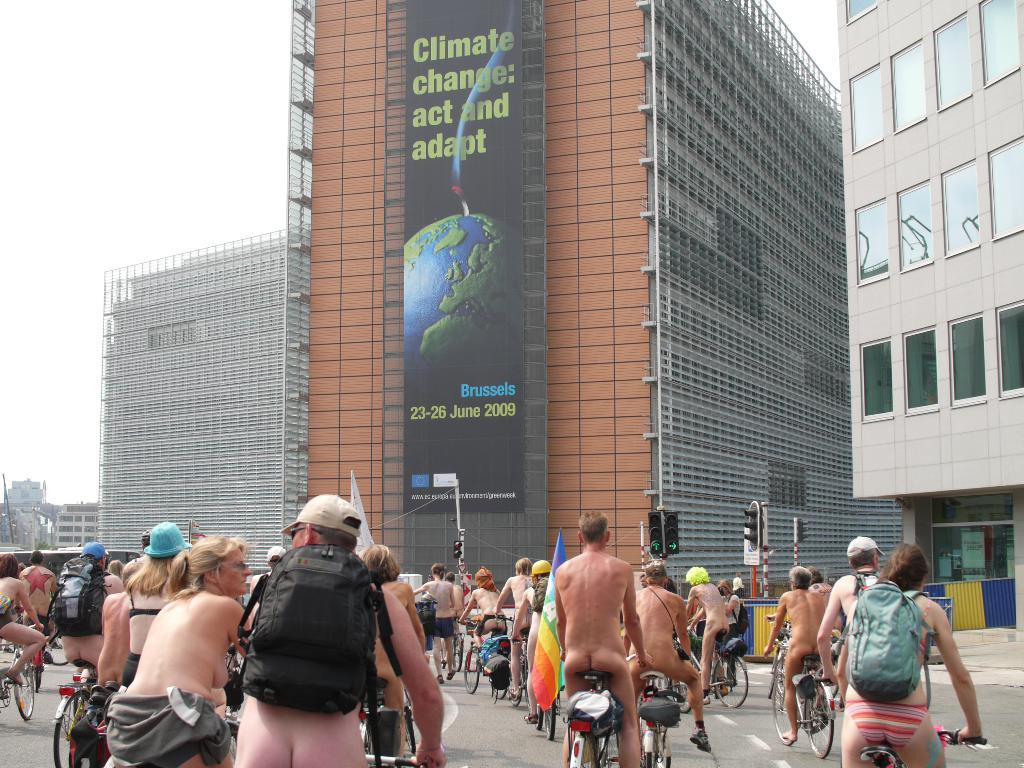Where was the image taken? The image is taken outdoors. What are the people in the image doing? The people are riding bicycles. On what surface are the bicycles? The bicycles are on a road. What can be seen in front of the people? There are buildings and a hoarding in front of the people. What part of the natural environment is visible in the image? The sky is visible in the image. What type of tools is the carpenter using in the image? There is no carpenter present in the image, and therefore no tools can be observed. How many sticks are being held by the people in the image? There are no sticks visible in the image; the people are riding bicycles. 